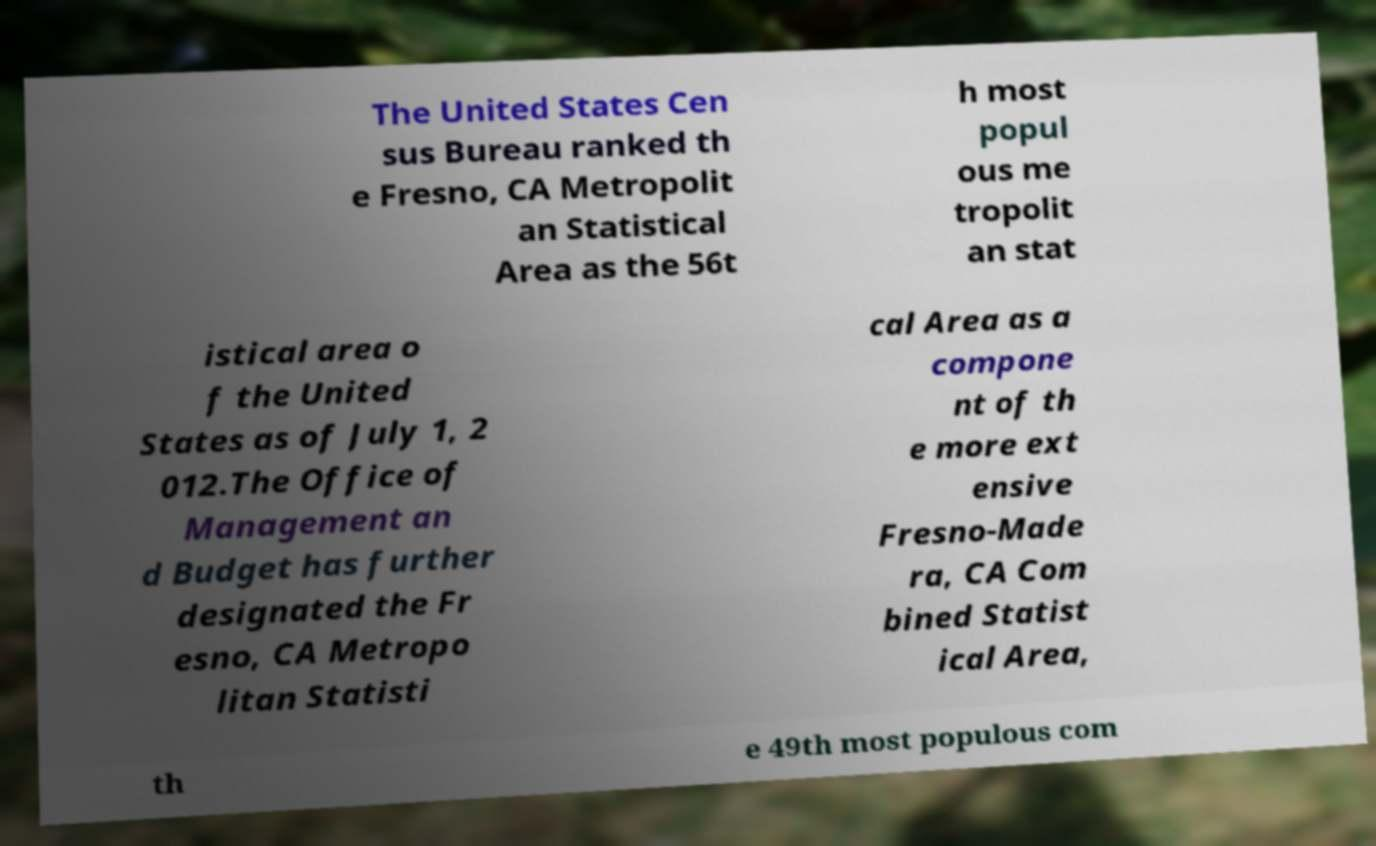Can you read and provide the text displayed in the image?This photo seems to have some interesting text. Can you extract and type it out for me? The United States Cen sus Bureau ranked th e Fresno, CA Metropolit an Statistical Area as the 56t h most popul ous me tropolit an stat istical area o f the United States as of July 1, 2 012.The Office of Management an d Budget has further designated the Fr esno, CA Metropo litan Statisti cal Area as a compone nt of th e more ext ensive Fresno-Made ra, CA Com bined Statist ical Area, th e 49th most populous com 